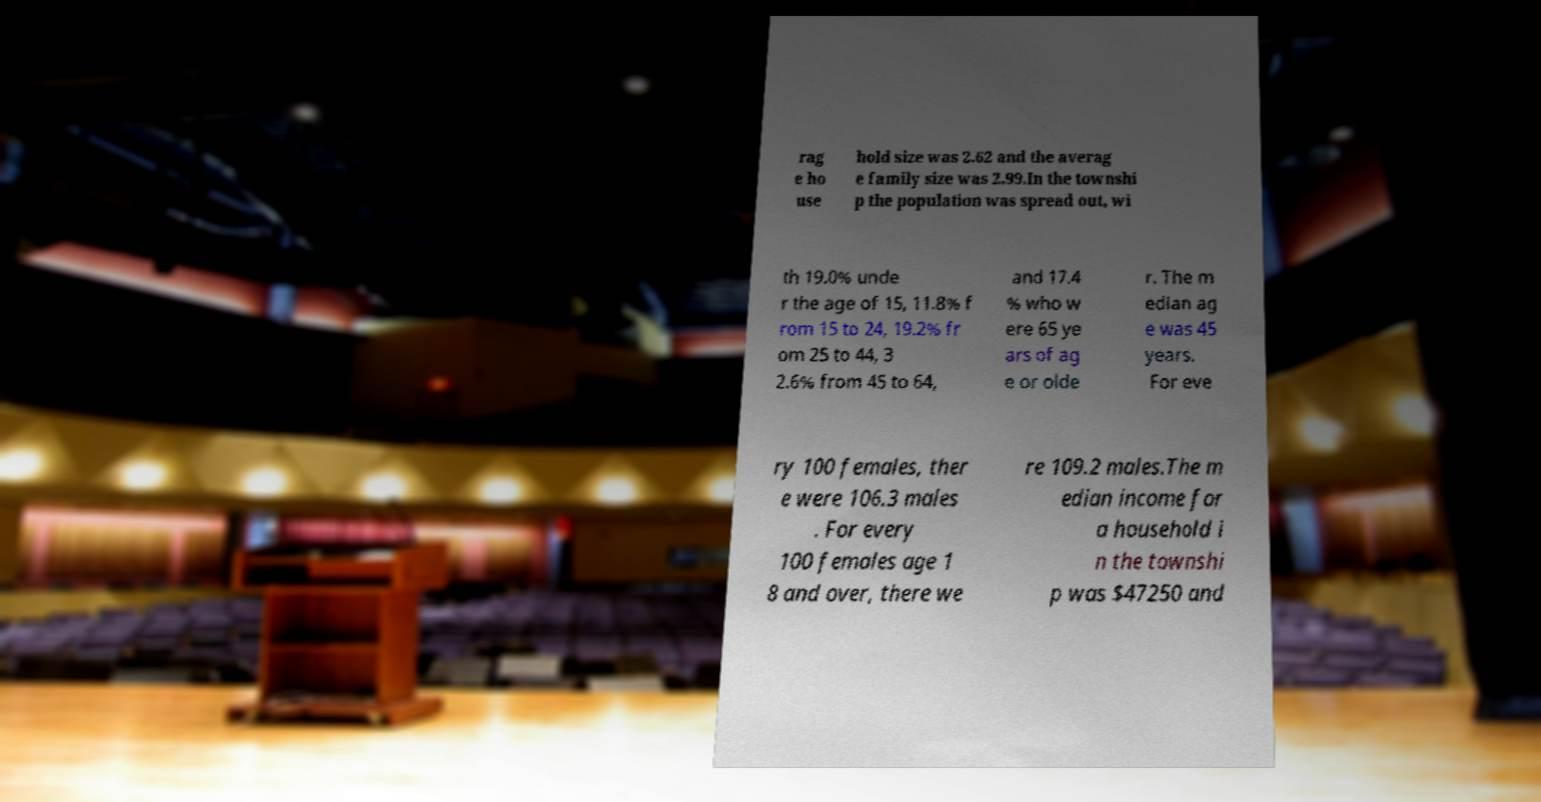Could you extract and type out the text from this image? rag e ho use hold size was 2.62 and the averag e family size was 2.99.In the townshi p the population was spread out, wi th 19.0% unde r the age of 15, 11.8% f rom 15 to 24, 19.2% fr om 25 to 44, 3 2.6% from 45 to 64, and 17.4 % who w ere 65 ye ars of ag e or olde r. The m edian ag e was 45 years. For eve ry 100 females, ther e were 106.3 males . For every 100 females age 1 8 and over, there we re 109.2 males.The m edian income for a household i n the townshi p was $47250 and 